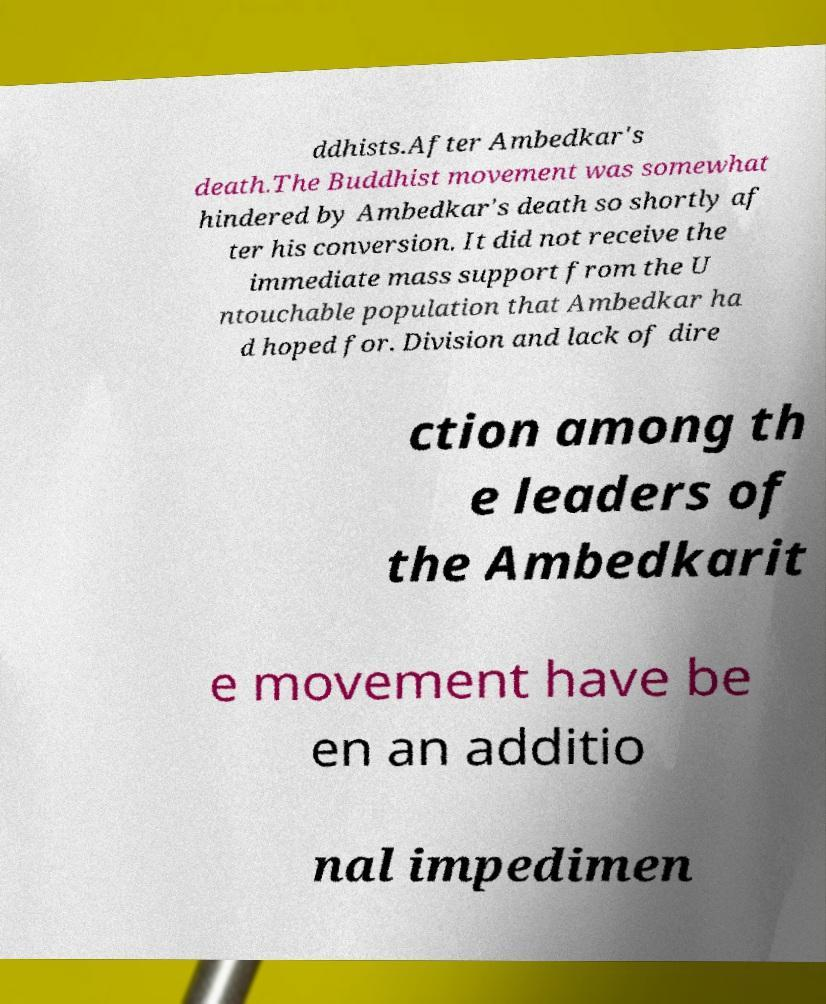Please identify and transcribe the text found in this image. ddhists.After Ambedkar's death.The Buddhist movement was somewhat hindered by Ambedkar's death so shortly af ter his conversion. It did not receive the immediate mass support from the U ntouchable population that Ambedkar ha d hoped for. Division and lack of dire ction among th e leaders of the Ambedkarit e movement have be en an additio nal impedimen 